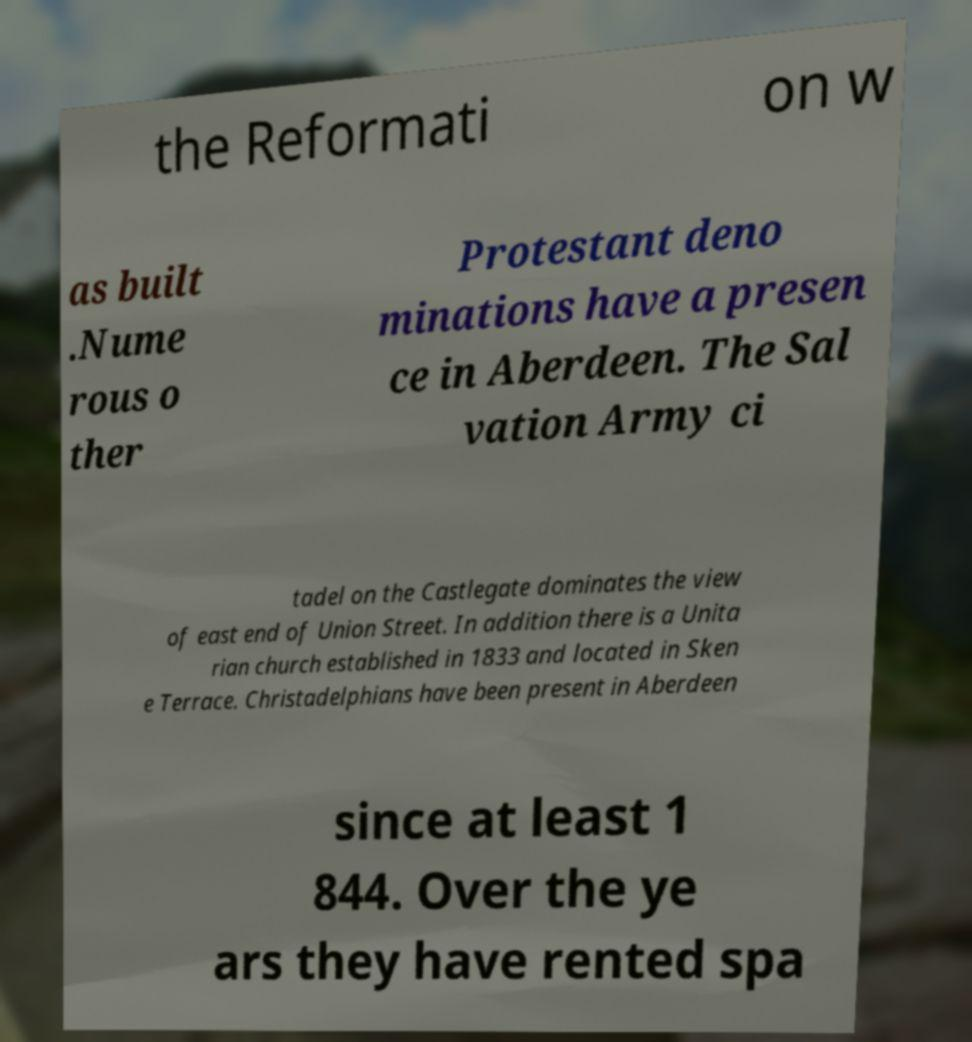There's text embedded in this image that I need extracted. Can you transcribe it verbatim? the Reformati on w as built .Nume rous o ther Protestant deno minations have a presen ce in Aberdeen. The Sal vation Army ci tadel on the Castlegate dominates the view of east end of Union Street. In addition there is a Unita rian church established in 1833 and located in Sken e Terrace. Christadelphians have been present in Aberdeen since at least 1 844. Over the ye ars they have rented spa 